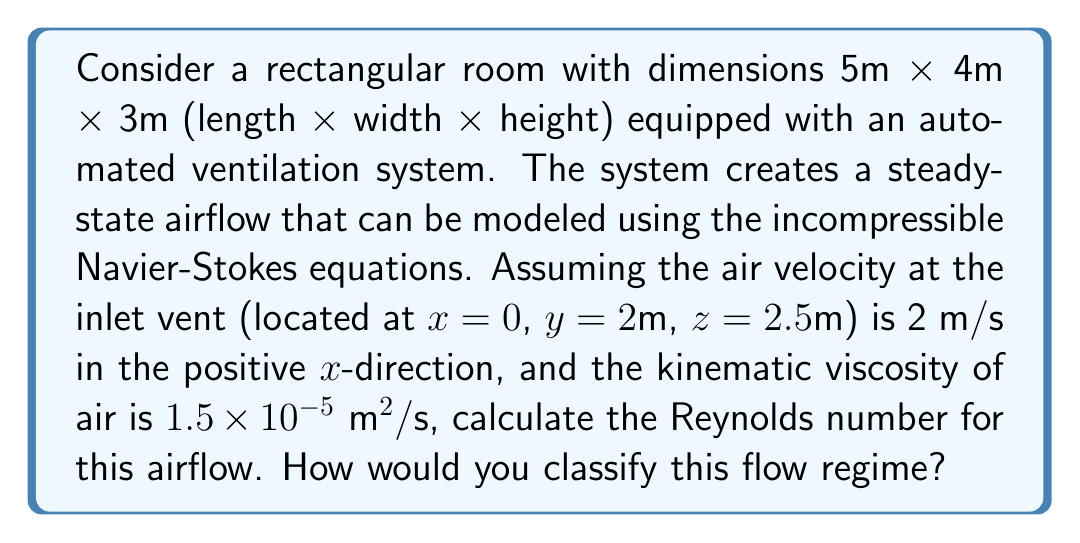Can you answer this question? To solve this problem, we need to follow these steps:

1) The Reynolds number (Re) is a dimensionless quantity that helps predict flow patterns in different fluid flow situations. It is defined as:

   $$ Re = \frac{UL}{\nu} $$

   where:
   $U$ is the characteristic velocity (m/s)
   $L$ is the characteristic length (m)
   $\nu$ is the kinematic viscosity of the fluid (m²/s)

2) We are given:
   - Velocity at inlet, $U = 2 \text{ m/s}$
   - Kinematic viscosity of air, $\nu = 1.5 \times 10^{-5} \text{ m}^2/\text{s}$

3) For the characteristic length, we'll use the hydraulic diameter of the room. For a rectangular duct, this is given by:

   $$ D_h = \frac{4A}{P} $$

   where $A$ is the cross-sectional area and $P$ is the wetted perimeter.

4) Calculate the cross-sectional area:
   $$ A = 4\text{ m} \times 3\text{ m} = 12 \text{ m}^2 $$

5) Calculate the wetted perimeter:
   $$ P = 2(4\text{ m} + 3\text{ m}) = 14 \text{ m} $$

6) Calculate the hydraulic diameter:
   $$ D_h = \frac{4 \times 12 \text{ m}^2}{14 \text{ m}} = 3.43 \text{ m} $$

7) Now we can calculate the Reynolds number:
   $$ Re = \frac{UL}{\nu} = \frac{2 \text{ m/s} \times 3.43 \text{ m}}{1.5 \times 10^{-5} \text{ m}^2/\text{s}} = 457,333.33 $$

8) In fluid dynamics:
   - Laminar flow typically occurs at Re < 2300
   - Transitional flow typically occurs at 2300 < Re < 4000
   - Turbulent flow typically occurs at Re > 4000

   With Re ≈ 457,333, this flow is well into the turbulent regime.
Answer: The Reynolds number is approximately 457,333. This indicates a turbulent flow regime. 